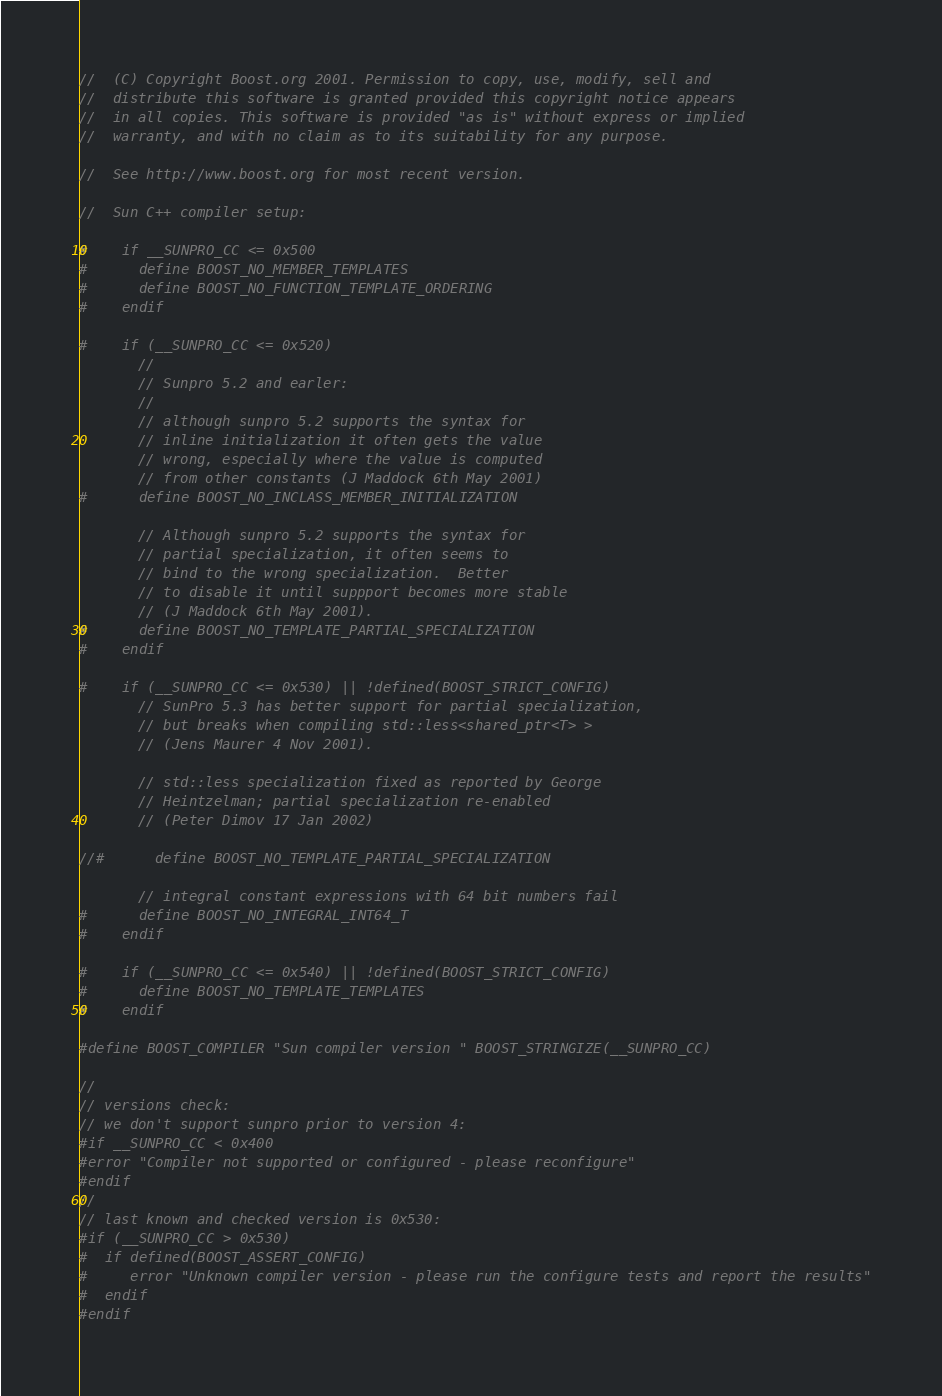<code> <loc_0><loc_0><loc_500><loc_500><_C++_>//  (C) Copyright Boost.org 2001. Permission to copy, use, modify, sell and
//  distribute this software is granted provided this copyright notice appears
//  in all copies. This software is provided "as is" without express or implied
//  warranty, and with no claim as to its suitability for any purpose.

//  See http://www.boost.org for most recent version.

//  Sun C++ compiler setup:

#    if __SUNPRO_CC <= 0x500
#      define BOOST_NO_MEMBER_TEMPLATES
#      define BOOST_NO_FUNCTION_TEMPLATE_ORDERING
#    endif

#    if (__SUNPRO_CC <= 0x520)
       //
       // Sunpro 5.2 and earler:
       //
       // although sunpro 5.2 supports the syntax for
       // inline initialization it often gets the value
       // wrong, especially where the value is computed
       // from other constants (J Maddock 6th May 2001)
#      define BOOST_NO_INCLASS_MEMBER_INITIALIZATION

       // Although sunpro 5.2 supports the syntax for
       // partial specialization, it often seems to
       // bind to the wrong specialization.  Better
       // to disable it until suppport becomes more stable
       // (J Maddock 6th May 2001).
#      define BOOST_NO_TEMPLATE_PARTIAL_SPECIALIZATION
#    endif

#    if (__SUNPRO_CC <= 0x530) || !defined(BOOST_STRICT_CONFIG)
       // SunPro 5.3 has better support for partial specialization,
       // but breaks when compiling std::less<shared_ptr<T> >
       // (Jens Maurer 4 Nov 2001).

       // std::less specialization fixed as reported by George
       // Heintzelman; partial specialization re-enabled
       // (Peter Dimov 17 Jan 2002)

//#      define BOOST_NO_TEMPLATE_PARTIAL_SPECIALIZATION

       // integral constant expressions with 64 bit numbers fail
#      define BOOST_NO_INTEGRAL_INT64_T
#    endif

#    if (__SUNPRO_CC <= 0x540) || !defined(BOOST_STRICT_CONFIG)
#      define BOOST_NO_TEMPLATE_TEMPLATES
#    endif

#define BOOST_COMPILER "Sun compiler version " BOOST_STRINGIZE(__SUNPRO_CC)

//
// versions check:
// we don't support sunpro prior to version 4:
#if __SUNPRO_CC < 0x400
#error "Compiler not supported or configured - please reconfigure"
#endif
//
// last known and checked version is 0x530:
#if (__SUNPRO_CC > 0x530)
#  if defined(BOOST_ASSERT_CONFIG)
#     error "Unknown compiler version - please run the configure tests and report the results"
#  endif
#endif





</code> 